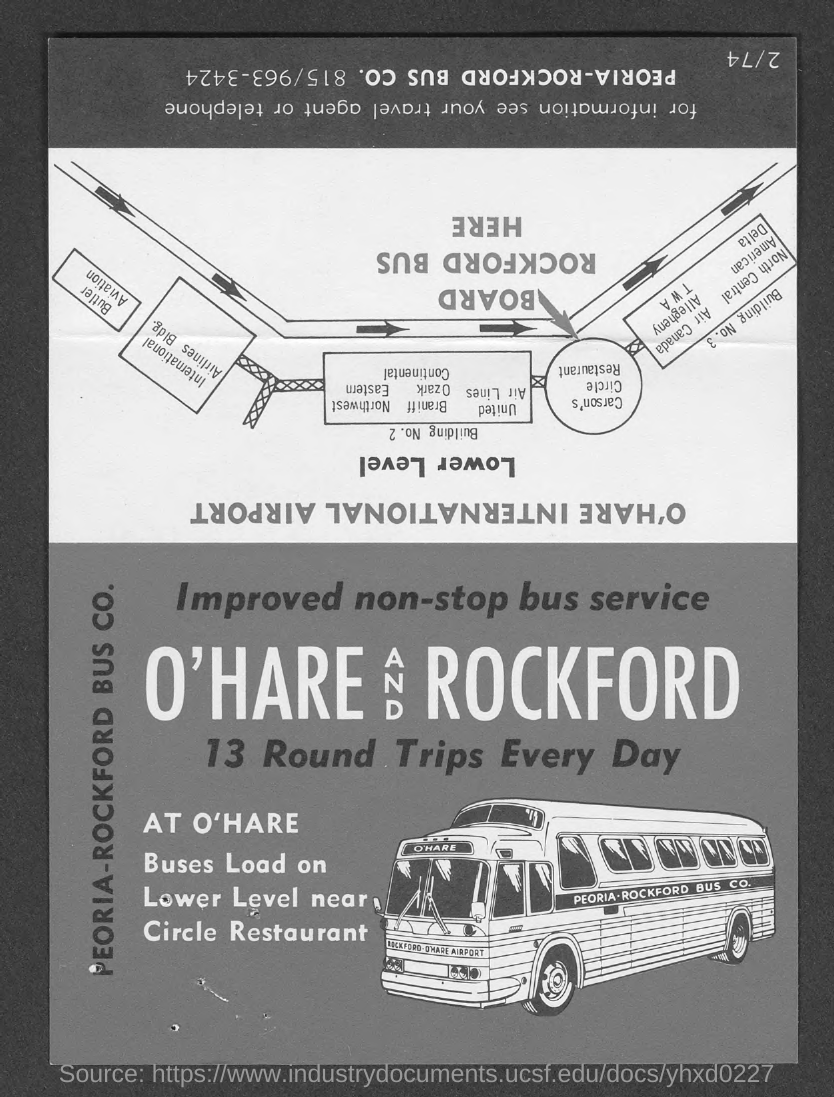How many round trips everyday?
Provide a succinct answer. 13. 